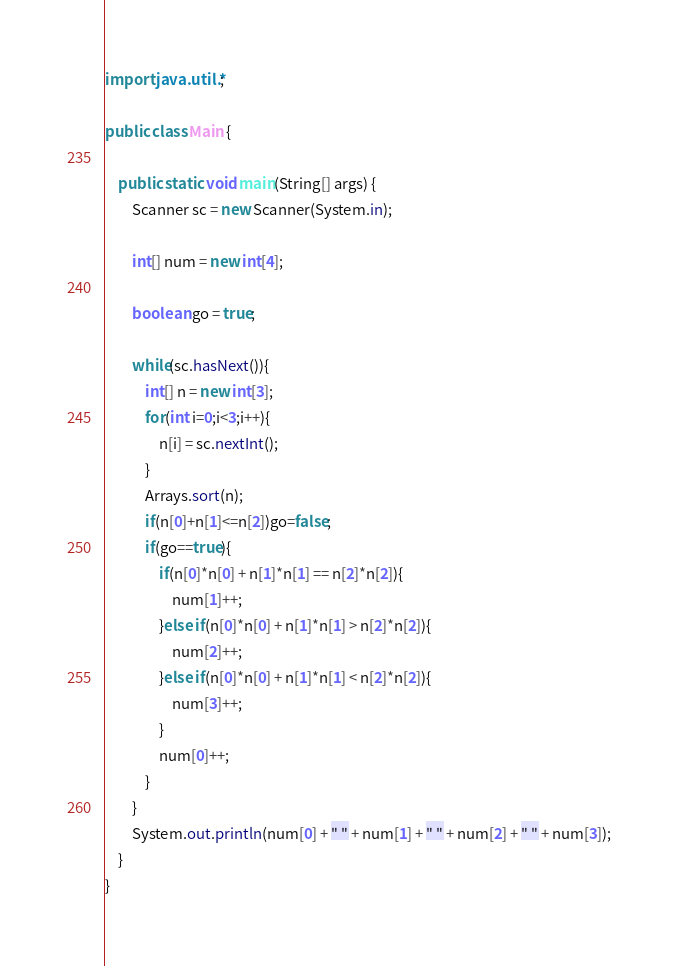Convert code to text. <code><loc_0><loc_0><loc_500><loc_500><_Java_>import java.util.*;

public class Main {

	public static void main(String[] args) {
		Scanner sc = new Scanner(System.in);
		
		int[] num = new int[4];
		
		boolean go = true;

		while(sc.hasNext()){
			int[] n = new int[3];
			for(int i=0;i<3;i++){
				n[i] = sc.nextInt();
			}
			Arrays.sort(n);
			if(n[0]+n[1]<=n[2])go=false;
			if(go==true){
				if(n[0]*n[0] + n[1]*n[1] == n[2]*n[2]){
					num[1]++;
				}else if(n[0]*n[0] + n[1]*n[1] > n[2]*n[2]){
					num[2]++;
				}else if(n[0]*n[0] + n[1]*n[1] < n[2]*n[2]){
					num[3]++;
				}
				num[0]++;
			}
		}
		System.out.println(num[0] + " " + num[1] + " " + num[2] + " " + num[3]);
	}
}</code> 